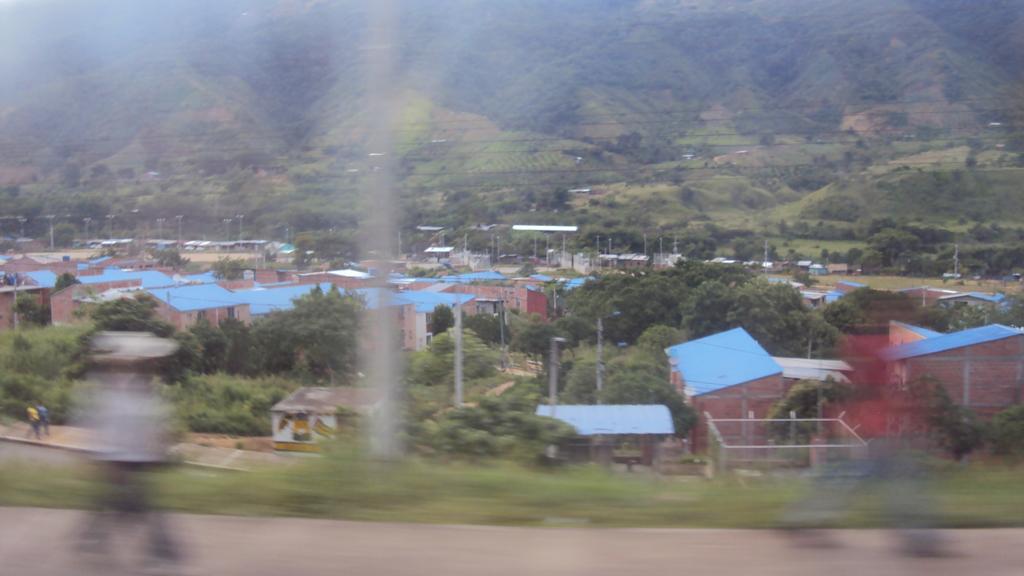Please provide a concise description of this image. In this image we can see people's, houses, wires and trees. At the bottom of the image, we can see people are walking on the road. At the top of the image, there are trees on the mountains. 